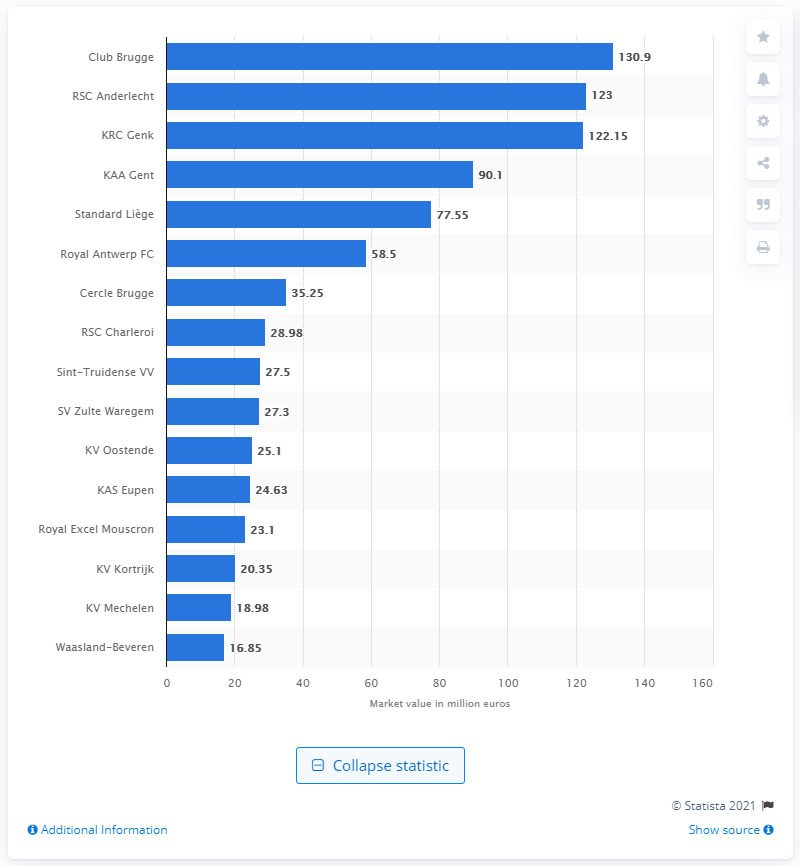Draw attention to some important aspects in this diagram. The market value of RSC Anderlecht was $123... KRC Genk placed third in the 2019 Belgium Jupiler Pro League. In 2019, the market value of Club Brugge was 130.9 million. 